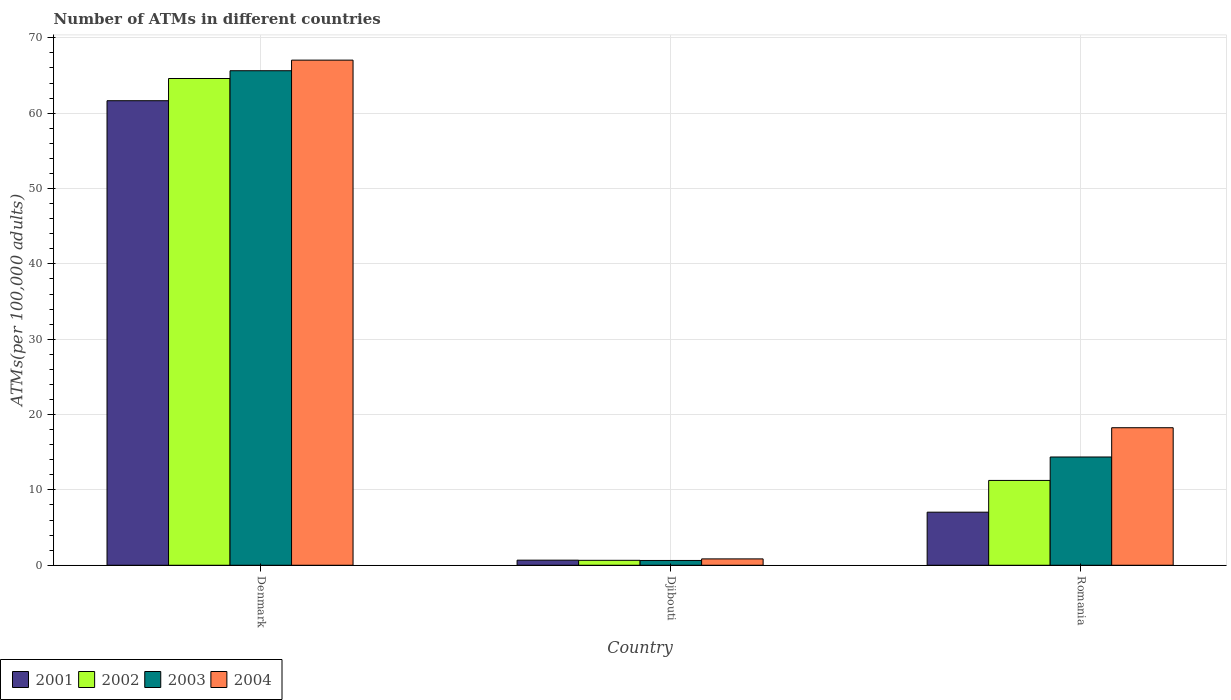How many different coloured bars are there?
Give a very brief answer. 4. How many groups of bars are there?
Provide a succinct answer. 3. Are the number of bars per tick equal to the number of legend labels?
Provide a short and direct response. Yes. Are the number of bars on each tick of the X-axis equal?
Ensure brevity in your answer.  Yes. How many bars are there on the 1st tick from the left?
Offer a very short reply. 4. What is the label of the 3rd group of bars from the left?
Your answer should be compact. Romania. What is the number of ATMs in 2002 in Denmark?
Provide a short and direct response. 64.61. Across all countries, what is the maximum number of ATMs in 2001?
Make the answer very short. 61.66. Across all countries, what is the minimum number of ATMs in 2002?
Provide a succinct answer. 0.66. In which country was the number of ATMs in 2001 minimum?
Provide a short and direct response. Djibouti. What is the total number of ATMs in 2003 in the graph?
Your response must be concise. 80.65. What is the difference between the number of ATMs in 2004 in Denmark and that in Djibouti?
Offer a very short reply. 66.2. What is the difference between the number of ATMs in 2002 in Djibouti and the number of ATMs in 2004 in Denmark?
Your answer should be compact. -66.39. What is the average number of ATMs in 2003 per country?
Ensure brevity in your answer.  26.88. What is the difference between the number of ATMs of/in 2001 and number of ATMs of/in 2004 in Romania?
Make the answer very short. -11.21. In how many countries, is the number of ATMs in 2003 greater than 14?
Provide a short and direct response. 2. What is the ratio of the number of ATMs in 2001 in Djibouti to that in Romania?
Offer a terse response. 0.1. Is the number of ATMs in 2001 in Djibouti less than that in Romania?
Make the answer very short. Yes. Is the difference between the number of ATMs in 2001 in Denmark and Romania greater than the difference between the number of ATMs in 2004 in Denmark and Romania?
Offer a very short reply. Yes. What is the difference between the highest and the second highest number of ATMs in 2001?
Your response must be concise. -60.98. What is the difference between the highest and the lowest number of ATMs in 2001?
Provide a short and direct response. 60.98. How many countries are there in the graph?
Your answer should be compact. 3. What is the difference between two consecutive major ticks on the Y-axis?
Ensure brevity in your answer.  10. Does the graph contain grids?
Keep it short and to the point. Yes. What is the title of the graph?
Ensure brevity in your answer.  Number of ATMs in different countries. What is the label or title of the X-axis?
Your answer should be compact. Country. What is the label or title of the Y-axis?
Offer a terse response. ATMs(per 100,0 adults). What is the ATMs(per 100,000 adults) in 2001 in Denmark?
Keep it short and to the point. 61.66. What is the ATMs(per 100,000 adults) in 2002 in Denmark?
Give a very brief answer. 64.61. What is the ATMs(per 100,000 adults) in 2003 in Denmark?
Your answer should be compact. 65.64. What is the ATMs(per 100,000 adults) of 2004 in Denmark?
Provide a succinct answer. 67.04. What is the ATMs(per 100,000 adults) of 2001 in Djibouti?
Make the answer very short. 0.68. What is the ATMs(per 100,000 adults) in 2002 in Djibouti?
Offer a terse response. 0.66. What is the ATMs(per 100,000 adults) in 2003 in Djibouti?
Provide a short and direct response. 0.64. What is the ATMs(per 100,000 adults) in 2004 in Djibouti?
Provide a short and direct response. 0.84. What is the ATMs(per 100,000 adults) in 2001 in Romania?
Provide a succinct answer. 7.04. What is the ATMs(per 100,000 adults) of 2002 in Romania?
Make the answer very short. 11.26. What is the ATMs(per 100,000 adults) of 2003 in Romania?
Offer a terse response. 14.37. What is the ATMs(per 100,000 adults) in 2004 in Romania?
Make the answer very short. 18.26. Across all countries, what is the maximum ATMs(per 100,000 adults) of 2001?
Your answer should be compact. 61.66. Across all countries, what is the maximum ATMs(per 100,000 adults) in 2002?
Your response must be concise. 64.61. Across all countries, what is the maximum ATMs(per 100,000 adults) in 2003?
Offer a very short reply. 65.64. Across all countries, what is the maximum ATMs(per 100,000 adults) in 2004?
Offer a very short reply. 67.04. Across all countries, what is the minimum ATMs(per 100,000 adults) of 2001?
Offer a very short reply. 0.68. Across all countries, what is the minimum ATMs(per 100,000 adults) in 2002?
Ensure brevity in your answer.  0.66. Across all countries, what is the minimum ATMs(per 100,000 adults) in 2003?
Offer a very short reply. 0.64. Across all countries, what is the minimum ATMs(per 100,000 adults) of 2004?
Make the answer very short. 0.84. What is the total ATMs(per 100,000 adults) of 2001 in the graph?
Provide a succinct answer. 69.38. What is the total ATMs(per 100,000 adults) in 2002 in the graph?
Offer a very short reply. 76.52. What is the total ATMs(per 100,000 adults) of 2003 in the graph?
Provide a succinct answer. 80.65. What is the total ATMs(per 100,000 adults) in 2004 in the graph?
Your answer should be compact. 86.14. What is the difference between the ATMs(per 100,000 adults) of 2001 in Denmark and that in Djibouti?
Give a very brief answer. 60.98. What is the difference between the ATMs(per 100,000 adults) in 2002 in Denmark and that in Djibouti?
Provide a succinct answer. 63.95. What is the difference between the ATMs(per 100,000 adults) of 2003 in Denmark and that in Djibouti?
Give a very brief answer. 65. What is the difference between the ATMs(per 100,000 adults) in 2004 in Denmark and that in Djibouti?
Offer a very short reply. 66.2. What is the difference between the ATMs(per 100,000 adults) of 2001 in Denmark and that in Romania?
Offer a very short reply. 54.61. What is the difference between the ATMs(per 100,000 adults) of 2002 in Denmark and that in Romania?
Your answer should be compact. 53.35. What is the difference between the ATMs(per 100,000 adults) of 2003 in Denmark and that in Romania?
Offer a very short reply. 51.27. What is the difference between the ATMs(per 100,000 adults) of 2004 in Denmark and that in Romania?
Your response must be concise. 48.79. What is the difference between the ATMs(per 100,000 adults) of 2001 in Djibouti and that in Romania?
Provide a succinct answer. -6.37. What is the difference between the ATMs(per 100,000 adults) in 2002 in Djibouti and that in Romania?
Your response must be concise. -10.6. What is the difference between the ATMs(per 100,000 adults) of 2003 in Djibouti and that in Romania?
Your answer should be very brief. -13.73. What is the difference between the ATMs(per 100,000 adults) in 2004 in Djibouti and that in Romania?
Your answer should be compact. -17.41. What is the difference between the ATMs(per 100,000 adults) in 2001 in Denmark and the ATMs(per 100,000 adults) in 2002 in Djibouti?
Your response must be concise. 61. What is the difference between the ATMs(per 100,000 adults) of 2001 in Denmark and the ATMs(per 100,000 adults) of 2003 in Djibouti?
Your answer should be compact. 61.02. What is the difference between the ATMs(per 100,000 adults) in 2001 in Denmark and the ATMs(per 100,000 adults) in 2004 in Djibouti?
Your response must be concise. 60.81. What is the difference between the ATMs(per 100,000 adults) of 2002 in Denmark and the ATMs(per 100,000 adults) of 2003 in Djibouti?
Offer a terse response. 63.97. What is the difference between the ATMs(per 100,000 adults) of 2002 in Denmark and the ATMs(per 100,000 adults) of 2004 in Djibouti?
Your answer should be compact. 63.76. What is the difference between the ATMs(per 100,000 adults) in 2003 in Denmark and the ATMs(per 100,000 adults) in 2004 in Djibouti?
Make the answer very short. 64.79. What is the difference between the ATMs(per 100,000 adults) of 2001 in Denmark and the ATMs(per 100,000 adults) of 2002 in Romania?
Provide a succinct answer. 50.4. What is the difference between the ATMs(per 100,000 adults) in 2001 in Denmark and the ATMs(per 100,000 adults) in 2003 in Romania?
Keep it short and to the point. 47.29. What is the difference between the ATMs(per 100,000 adults) in 2001 in Denmark and the ATMs(per 100,000 adults) in 2004 in Romania?
Your answer should be compact. 43.4. What is the difference between the ATMs(per 100,000 adults) of 2002 in Denmark and the ATMs(per 100,000 adults) of 2003 in Romania?
Provide a succinct answer. 50.24. What is the difference between the ATMs(per 100,000 adults) in 2002 in Denmark and the ATMs(per 100,000 adults) in 2004 in Romania?
Offer a terse response. 46.35. What is the difference between the ATMs(per 100,000 adults) of 2003 in Denmark and the ATMs(per 100,000 adults) of 2004 in Romania?
Keep it short and to the point. 47.38. What is the difference between the ATMs(per 100,000 adults) of 2001 in Djibouti and the ATMs(per 100,000 adults) of 2002 in Romania?
Keep it short and to the point. -10.58. What is the difference between the ATMs(per 100,000 adults) in 2001 in Djibouti and the ATMs(per 100,000 adults) in 2003 in Romania?
Make the answer very short. -13.69. What is the difference between the ATMs(per 100,000 adults) in 2001 in Djibouti and the ATMs(per 100,000 adults) in 2004 in Romania?
Offer a terse response. -17.58. What is the difference between the ATMs(per 100,000 adults) of 2002 in Djibouti and the ATMs(per 100,000 adults) of 2003 in Romania?
Make the answer very short. -13.71. What is the difference between the ATMs(per 100,000 adults) of 2002 in Djibouti and the ATMs(per 100,000 adults) of 2004 in Romania?
Offer a terse response. -17.6. What is the difference between the ATMs(per 100,000 adults) of 2003 in Djibouti and the ATMs(per 100,000 adults) of 2004 in Romania?
Your response must be concise. -17.62. What is the average ATMs(per 100,000 adults) of 2001 per country?
Offer a terse response. 23.13. What is the average ATMs(per 100,000 adults) of 2002 per country?
Keep it short and to the point. 25.51. What is the average ATMs(per 100,000 adults) of 2003 per country?
Offer a terse response. 26.88. What is the average ATMs(per 100,000 adults) in 2004 per country?
Your response must be concise. 28.71. What is the difference between the ATMs(per 100,000 adults) of 2001 and ATMs(per 100,000 adults) of 2002 in Denmark?
Make the answer very short. -2.95. What is the difference between the ATMs(per 100,000 adults) in 2001 and ATMs(per 100,000 adults) in 2003 in Denmark?
Your response must be concise. -3.98. What is the difference between the ATMs(per 100,000 adults) of 2001 and ATMs(per 100,000 adults) of 2004 in Denmark?
Give a very brief answer. -5.39. What is the difference between the ATMs(per 100,000 adults) of 2002 and ATMs(per 100,000 adults) of 2003 in Denmark?
Keep it short and to the point. -1.03. What is the difference between the ATMs(per 100,000 adults) in 2002 and ATMs(per 100,000 adults) in 2004 in Denmark?
Give a very brief answer. -2.44. What is the difference between the ATMs(per 100,000 adults) of 2003 and ATMs(per 100,000 adults) of 2004 in Denmark?
Your answer should be very brief. -1.41. What is the difference between the ATMs(per 100,000 adults) of 2001 and ATMs(per 100,000 adults) of 2002 in Djibouti?
Provide a short and direct response. 0.02. What is the difference between the ATMs(per 100,000 adults) in 2001 and ATMs(per 100,000 adults) in 2003 in Djibouti?
Provide a short and direct response. 0.04. What is the difference between the ATMs(per 100,000 adults) in 2001 and ATMs(per 100,000 adults) in 2004 in Djibouti?
Make the answer very short. -0.17. What is the difference between the ATMs(per 100,000 adults) of 2002 and ATMs(per 100,000 adults) of 2003 in Djibouti?
Make the answer very short. 0.02. What is the difference between the ATMs(per 100,000 adults) of 2002 and ATMs(per 100,000 adults) of 2004 in Djibouti?
Offer a terse response. -0.19. What is the difference between the ATMs(per 100,000 adults) in 2003 and ATMs(per 100,000 adults) in 2004 in Djibouti?
Offer a terse response. -0.21. What is the difference between the ATMs(per 100,000 adults) in 2001 and ATMs(per 100,000 adults) in 2002 in Romania?
Your answer should be very brief. -4.21. What is the difference between the ATMs(per 100,000 adults) of 2001 and ATMs(per 100,000 adults) of 2003 in Romania?
Offer a very short reply. -7.32. What is the difference between the ATMs(per 100,000 adults) in 2001 and ATMs(per 100,000 adults) in 2004 in Romania?
Offer a terse response. -11.21. What is the difference between the ATMs(per 100,000 adults) of 2002 and ATMs(per 100,000 adults) of 2003 in Romania?
Offer a very short reply. -3.11. What is the difference between the ATMs(per 100,000 adults) of 2002 and ATMs(per 100,000 adults) of 2004 in Romania?
Offer a terse response. -7. What is the difference between the ATMs(per 100,000 adults) in 2003 and ATMs(per 100,000 adults) in 2004 in Romania?
Offer a terse response. -3.89. What is the ratio of the ATMs(per 100,000 adults) in 2001 in Denmark to that in Djibouti?
Your response must be concise. 91.18. What is the ratio of the ATMs(per 100,000 adults) in 2002 in Denmark to that in Djibouti?
Provide a short and direct response. 98.45. What is the ratio of the ATMs(per 100,000 adults) of 2003 in Denmark to that in Djibouti?
Provide a succinct answer. 102.88. What is the ratio of the ATMs(per 100,000 adults) in 2004 in Denmark to that in Djibouti?
Your answer should be compact. 79.46. What is the ratio of the ATMs(per 100,000 adults) in 2001 in Denmark to that in Romania?
Your answer should be compact. 8.75. What is the ratio of the ATMs(per 100,000 adults) of 2002 in Denmark to that in Romania?
Offer a terse response. 5.74. What is the ratio of the ATMs(per 100,000 adults) of 2003 in Denmark to that in Romania?
Make the answer very short. 4.57. What is the ratio of the ATMs(per 100,000 adults) in 2004 in Denmark to that in Romania?
Your answer should be compact. 3.67. What is the ratio of the ATMs(per 100,000 adults) in 2001 in Djibouti to that in Romania?
Give a very brief answer. 0.1. What is the ratio of the ATMs(per 100,000 adults) in 2002 in Djibouti to that in Romania?
Offer a terse response. 0.06. What is the ratio of the ATMs(per 100,000 adults) in 2003 in Djibouti to that in Romania?
Provide a short and direct response. 0.04. What is the ratio of the ATMs(per 100,000 adults) of 2004 in Djibouti to that in Romania?
Give a very brief answer. 0.05. What is the difference between the highest and the second highest ATMs(per 100,000 adults) in 2001?
Give a very brief answer. 54.61. What is the difference between the highest and the second highest ATMs(per 100,000 adults) of 2002?
Offer a very short reply. 53.35. What is the difference between the highest and the second highest ATMs(per 100,000 adults) in 2003?
Your answer should be compact. 51.27. What is the difference between the highest and the second highest ATMs(per 100,000 adults) of 2004?
Ensure brevity in your answer.  48.79. What is the difference between the highest and the lowest ATMs(per 100,000 adults) of 2001?
Keep it short and to the point. 60.98. What is the difference between the highest and the lowest ATMs(per 100,000 adults) of 2002?
Your answer should be very brief. 63.95. What is the difference between the highest and the lowest ATMs(per 100,000 adults) of 2003?
Keep it short and to the point. 65. What is the difference between the highest and the lowest ATMs(per 100,000 adults) of 2004?
Give a very brief answer. 66.2. 